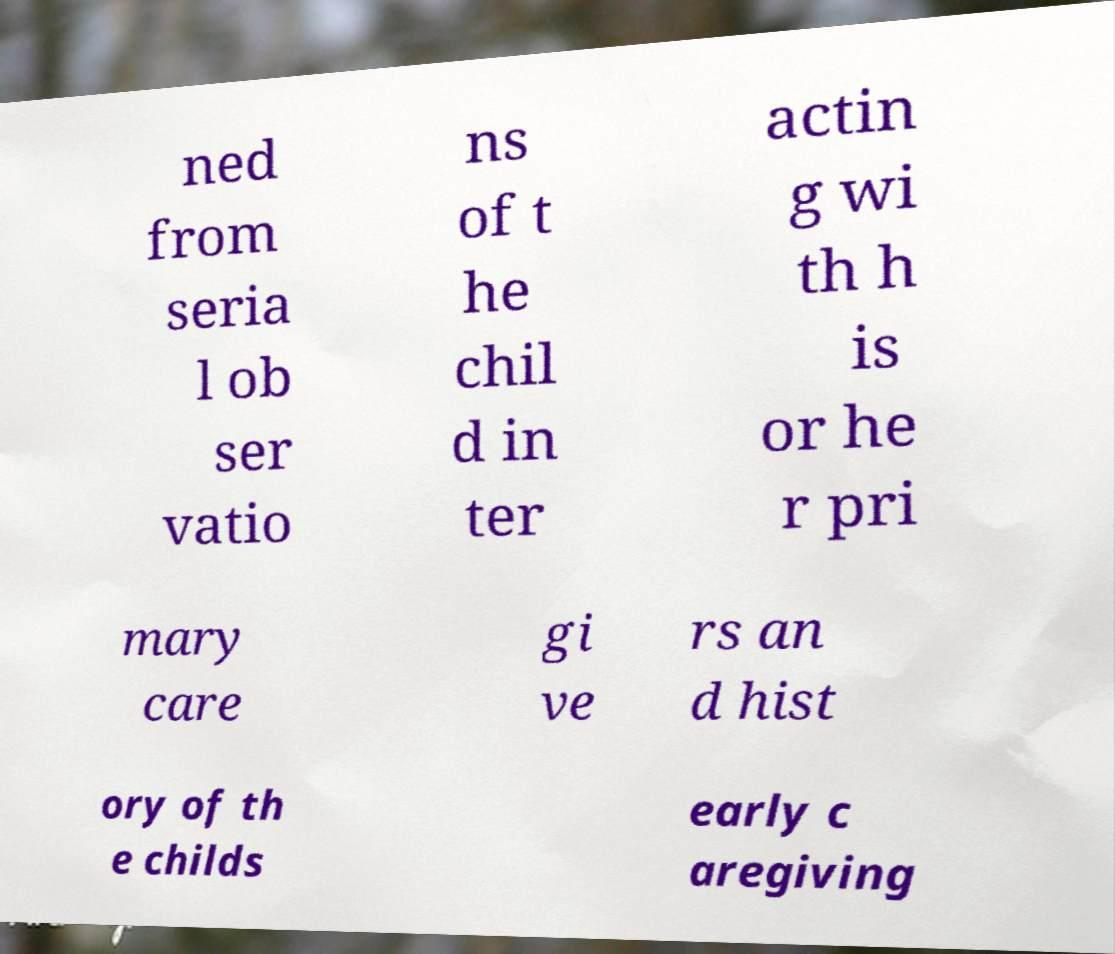What messages or text are displayed in this image? I need them in a readable, typed format. ned from seria l ob ser vatio ns of t he chil d in ter actin g wi th h is or he r pri mary care gi ve rs an d hist ory of th e childs early c aregiving 